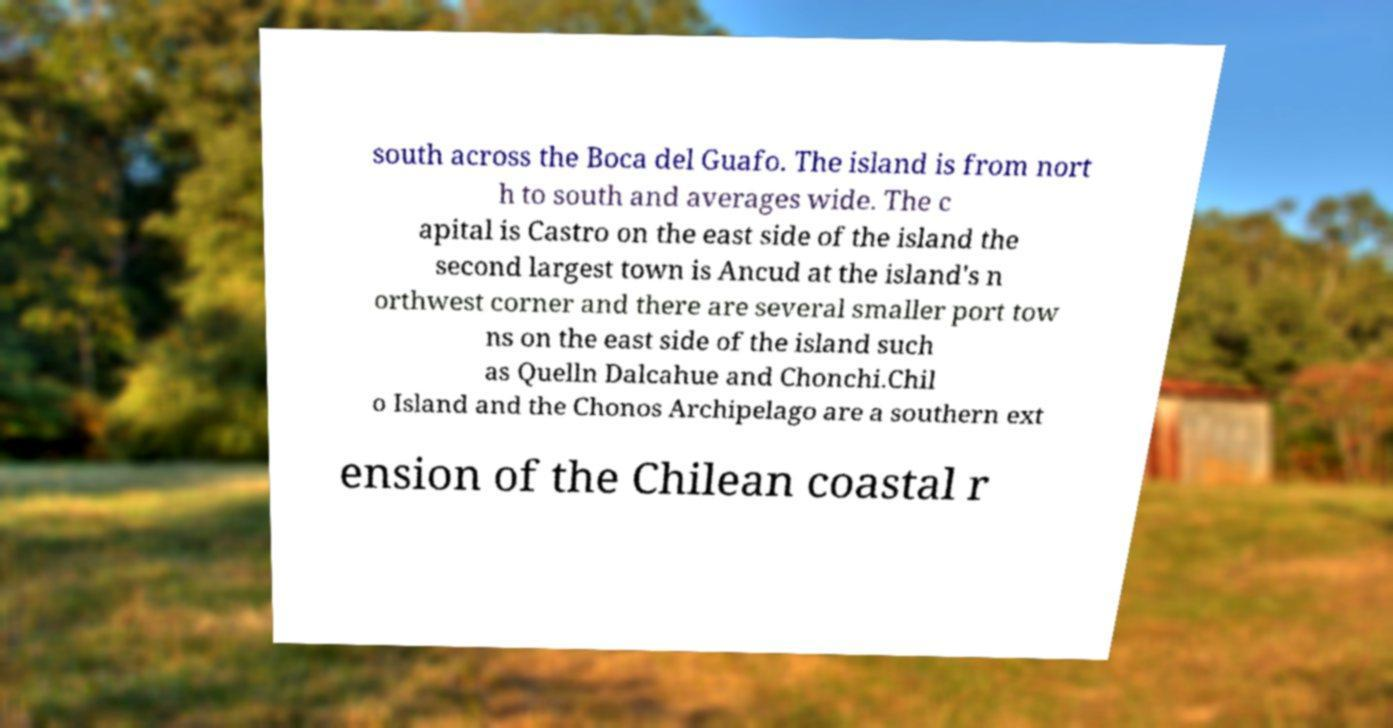There's text embedded in this image that I need extracted. Can you transcribe it verbatim? south across the Boca del Guafo. The island is from nort h to south and averages wide. The c apital is Castro on the east side of the island the second largest town is Ancud at the island's n orthwest corner and there are several smaller port tow ns on the east side of the island such as Quelln Dalcahue and Chonchi.Chil o Island and the Chonos Archipelago are a southern ext ension of the Chilean coastal r 